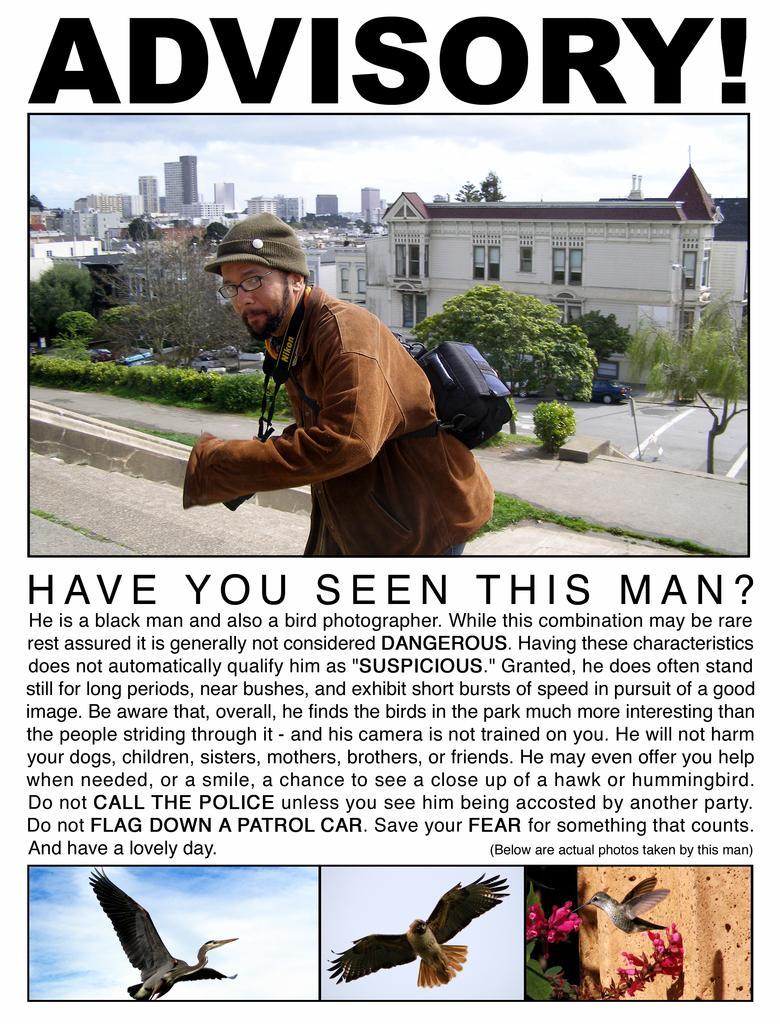In one or two sentences, can you explain what this image depicts? This image consists of a poster with a few images and text on it. There are a few images of birds, trees, plants, houses, buildings and a man. 